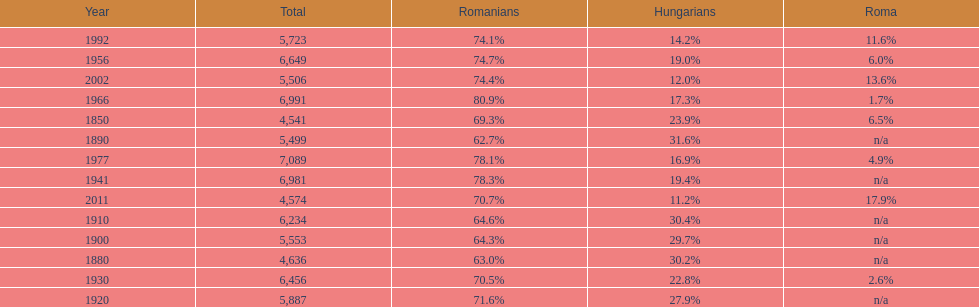Which year is previous to the year that had 74.1% in romanian population? 1977. 